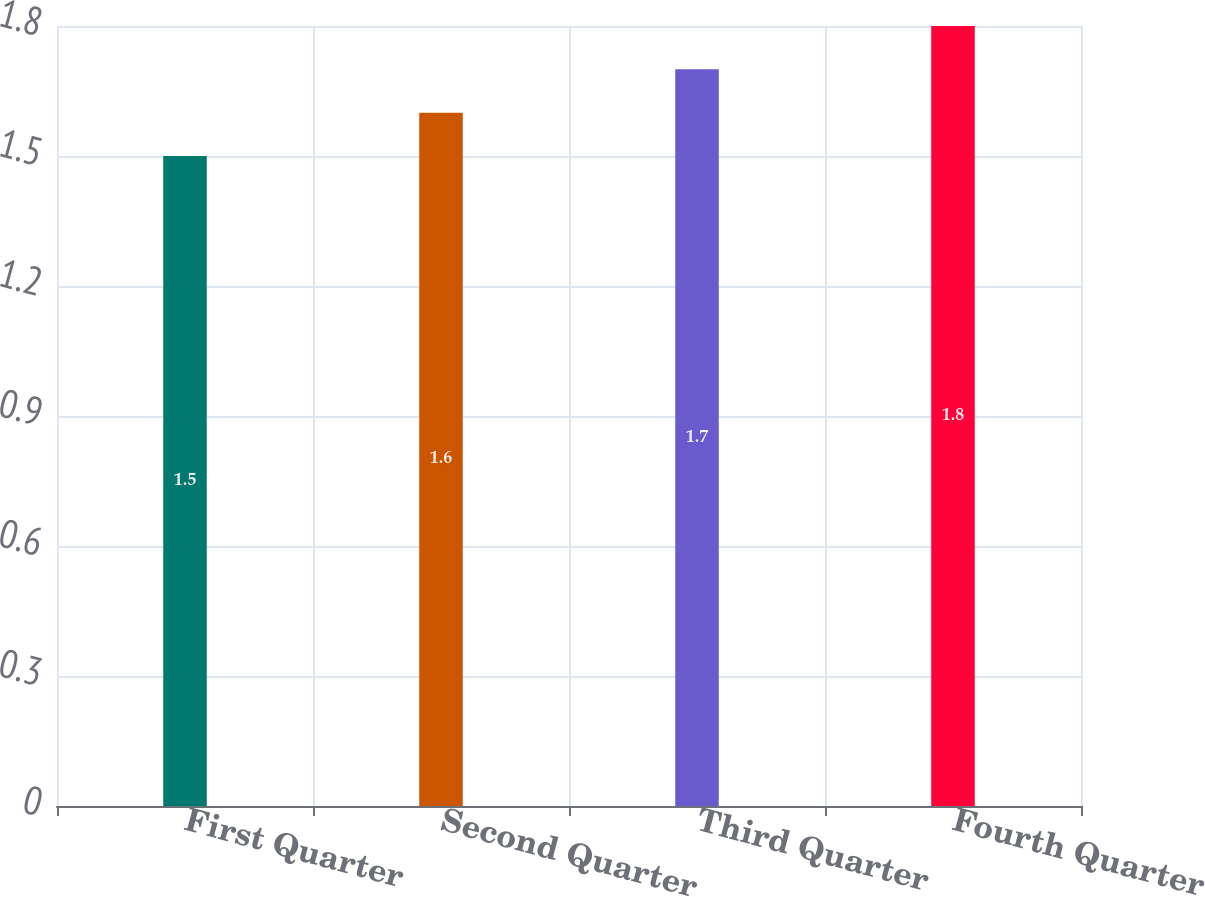<chart> <loc_0><loc_0><loc_500><loc_500><bar_chart><fcel>First Quarter<fcel>Second Quarter<fcel>Third Quarter<fcel>Fourth Quarter<nl><fcel>1.5<fcel>1.6<fcel>1.7<fcel>1.8<nl></chart> 